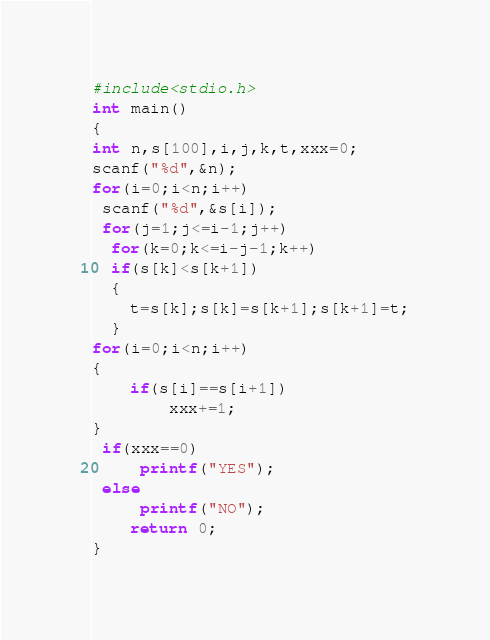Convert code to text. <code><loc_0><loc_0><loc_500><loc_500><_Awk_>#include<stdio.h>
int main()
{  
int n,s[100],i,j,k,t,xxx=0;
scanf("%d",&n);
for(i=0;i<n;i++)
 scanf("%d",&s[i]);
 for(j=1;j<=i-1;j++)
  for(k=0;k<=i-j-1;k++)
  if(s[k]<s[k+1])
  {
	t=s[k];s[k]=s[k+1];s[k+1]=t;
  }
for(i=0;i<n;i++)
{
	if(s[i]==s[i+1])
		xxx+=1;
}	 
 if(xxx==0)
	 printf("YES");
 else
	 printf("NO");
    return 0;
}</code> 